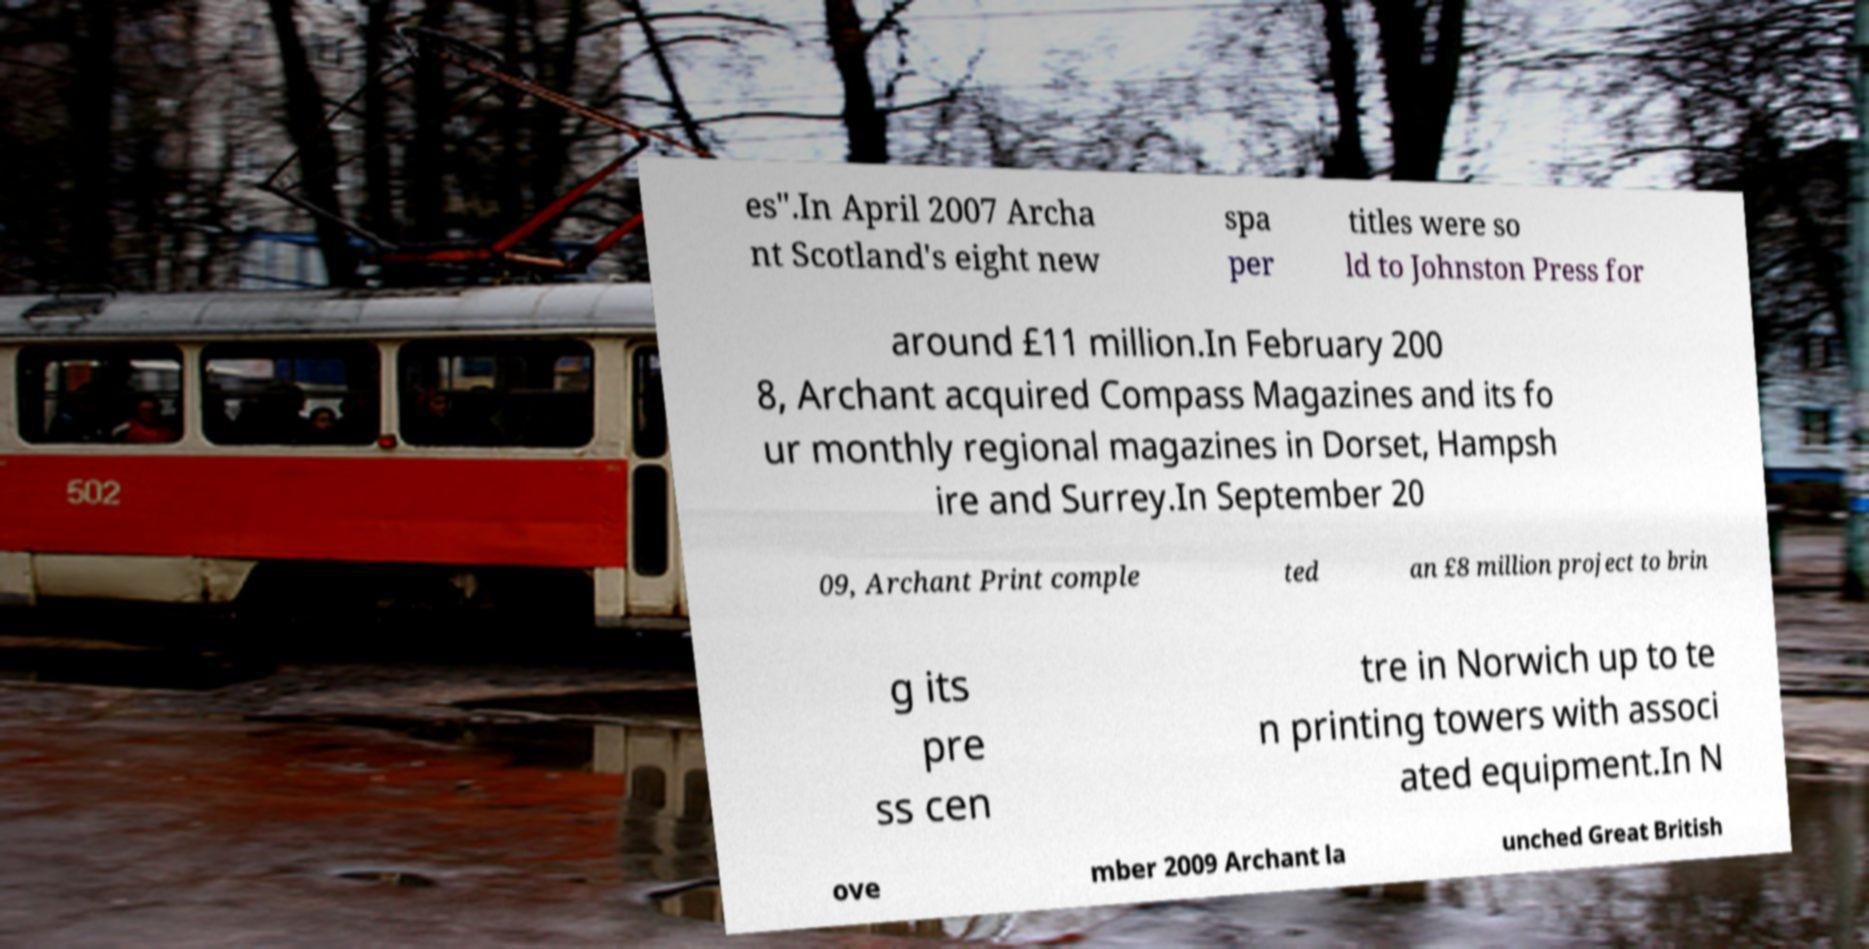Please identify and transcribe the text found in this image. es".In April 2007 Archa nt Scotland's eight new spa per titles were so ld to Johnston Press for around £11 million.In February 200 8, Archant acquired Compass Magazines and its fo ur monthly regional magazines in Dorset, Hampsh ire and Surrey.In September 20 09, Archant Print comple ted an £8 million project to brin g its pre ss cen tre in Norwich up to te n printing towers with associ ated equipment.In N ove mber 2009 Archant la unched Great British 